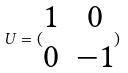<formula> <loc_0><loc_0><loc_500><loc_500>U = ( \begin{matrix} 1 & 0 \\ 0 & - 1 \end{matrix} )</formula> 